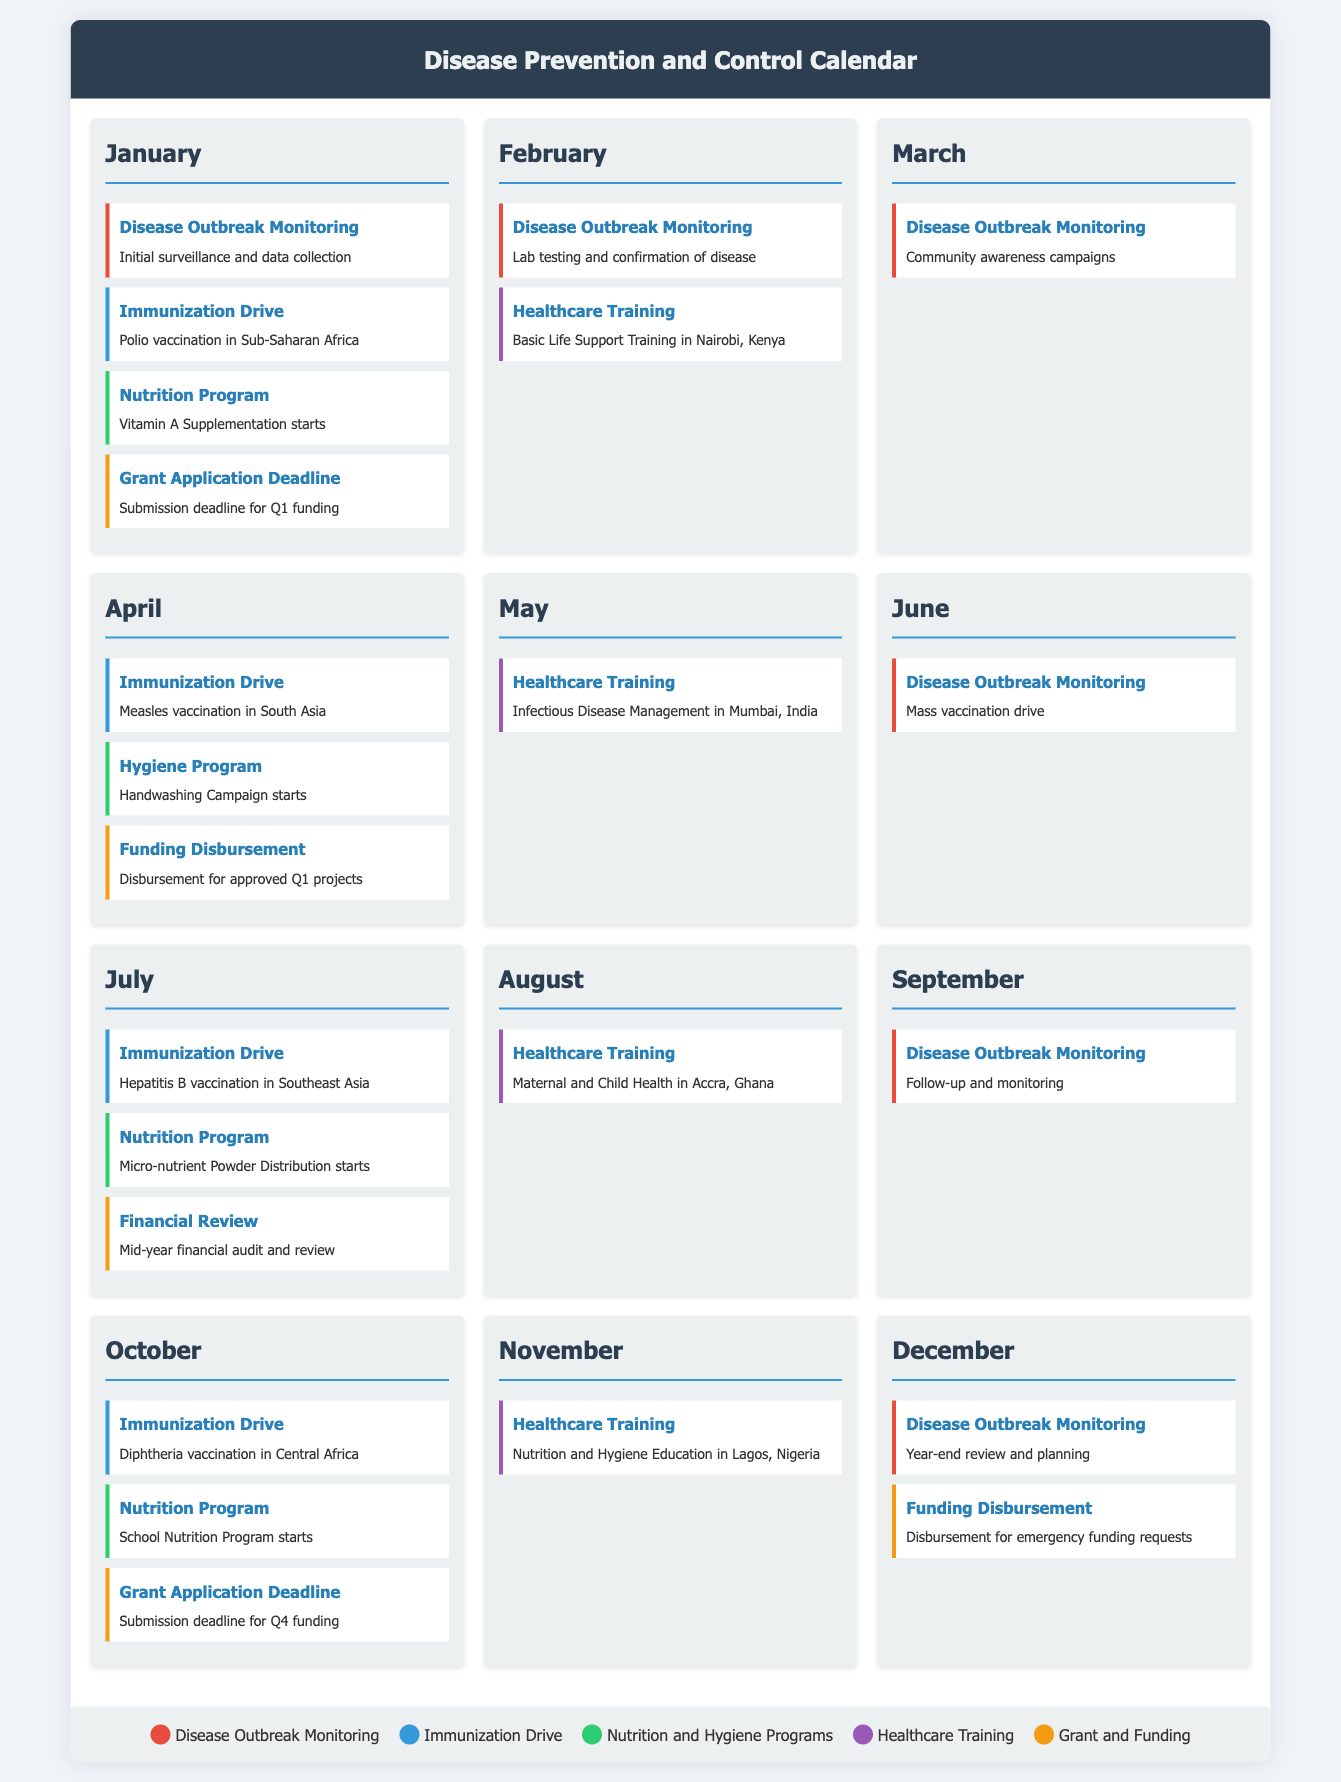What is the first event listed in January? The first event in January is related to disease outbreak monitoring, specifically initial surveillance and data collection.
Answer: Initial surveillance and data collection In which month does the Measles vaccination drive take place? The Measles vaccination drive is scheduled for April.
Answer: April How many healthcare training sessions are scheduled in November? There is one healthcare training session scheduled in November, which focuses on nutrition and hygiene education.
Answer: One What key action is taken in June? In June, the key action is a mass vaccination drive as part of disease outbreak monitoring.
Answer: Mass vaccination drive What is the grant application deadline mentioned for October? The document states a grant application deadline for October, specifically for Q4 funding.
Answer: Q4 funding 